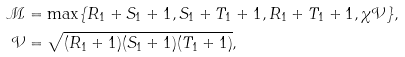Convert formula to latex. <formula><loc_0><loc_0><loc_500><loc_500>\mathcal { M } & = \max \{ R _ { 1 } + S _ { 1 } + 1 , S _ { 1 } + T _ { 1 } + 1 , R _ { 1 } + T _ { 1 } + 1 , \chi \mathcal { V } \} , \\ \mathcal { V } & = \sqrt { ( R _ { 1 } + 1 ) ( S _ { 1 } + 1 ) ( T _ { 1 } + 1 ) } ,</formula> 